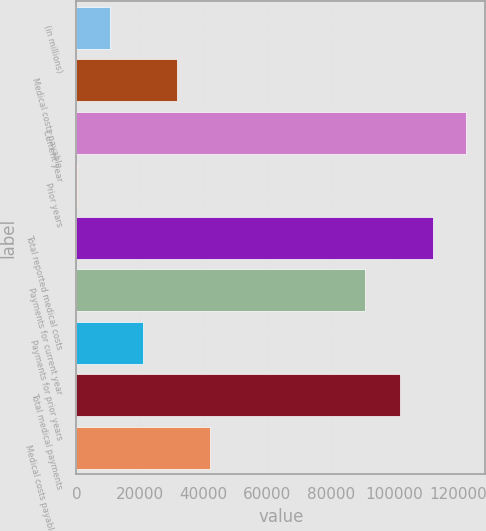<chart> <loc_0><loc_0><loc_500><loc_500><bar_chart><fcel>(in millions)<fcel>Medical costs payable<fcel>Current year<fcel>Prior years<fcel>Total reported medical costs<fcel>Payments for current year<fcel>Payments for prior years<fcel>Total medical payments<fcel>Medical costs payable end of<nl><fcel>10707.5<fcel>31482.5<fcel>122360<fcel>320<fcel>111972<fcel>90630<fcel>21095<fcel>101585<fcel>41870<nl></chart> 